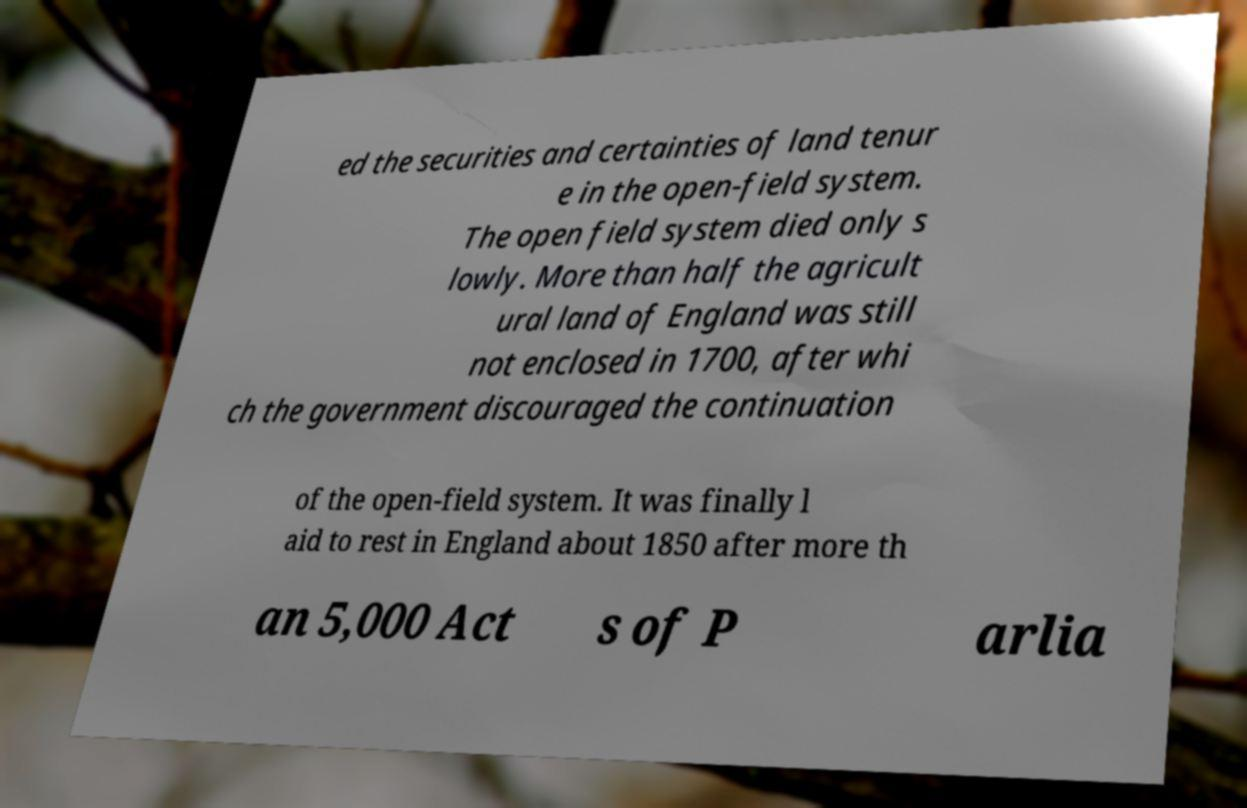There's text embedded in this image that I need extracted. Can you transcribe it verbatim? ed the securities and certainties of land tenur e in the open-field system. The open field system died only s lowly. More than half the agricult ural land of England was still not enclosed in 1700, after whi ch the government discouraged the continuation of the open-field system. It was finally l aid to rest in England about 1850 after more th an 5,000 Act s of P arlia 